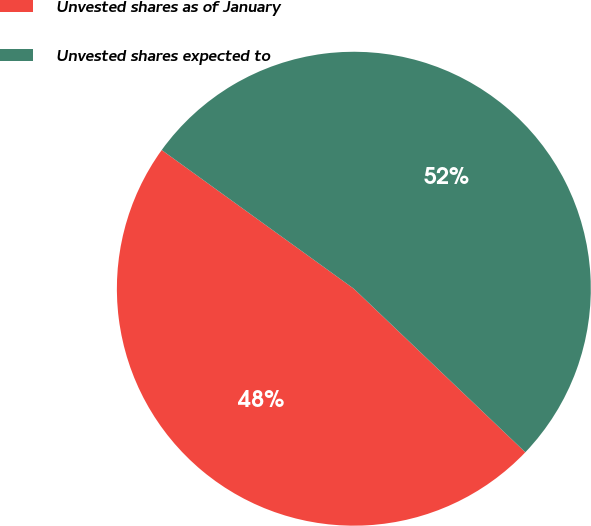Convert chart to OTSL. <chart><loc_0><loc_0><loc_500><loc_500><pie_chart><fcel>Unvested shares as of January<fcel>Unvested shares expected to<nl><fcel>47.83%<fcel>52.17%<nl></chart> 